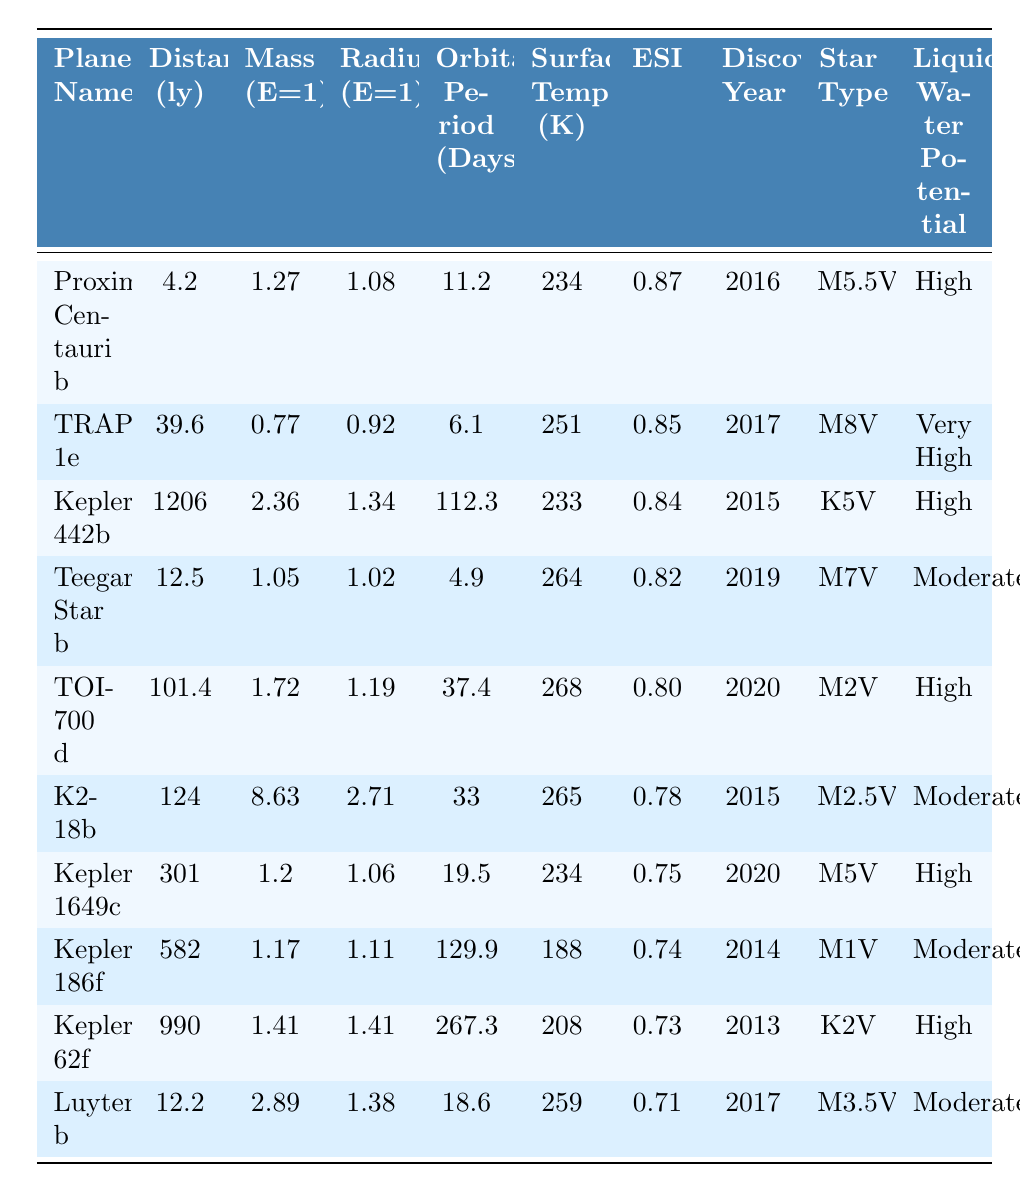What is the mass of TRAPPIST-1e in Earth masses? Looking at the row for TRAPPIST-1e, the mass is listed as 0.77 Earth masses.
Answer: 0.77 Which planet has the highest potential for liquid water? By examining the last column of the table, TRAPPIST-1e has the highest potential for liquid water, categorized as "Very High."
Answer: TRAPPIST-1e What is the distance of Kepler-62f in light-years? The distance entry for Kepler-62f in the table is 990 light-years.
Answer: 990 Calculate the average radius of planets with high potential for liquid water. The planets with high potential for liquid water are Proxima Centauri b, TRAPPIST-1e, Kepler-442b, TOI-700 d, Kepler-1649c, and Kepler-62f. Their radii are 1.08, 0.92, 1.34, 1.19, 1.06, and 1.41 respectively. Adding these gives 1.08 + 0.92 + 1.34 + 1.19 + 1.06 + 1.41 = 6.00. There are 6 planets, so the average radius is 6.00 / 6 = 1.00.
Answer: 1.00 Which planet discovered in 2019 has the highest surface temperature? Looking at the year column for 2019, the candidates are Teegarden's Star b, which has a surface temperature of 264 K. Checking the data shows that it is the only planet from 2019, so it is inherently the highest.
Answer: Teegarden's Star b Is K2-18b more massive than Proxima Centauri b? From the table, K2-18b has a mass of 8.63, while Proxima Centauri b has a mass of 1.27. Since 8.63 is greater than 1.27, K2-18b is indeed more massive than Proxima Centauri b.
Answer: Yes What is the orbital period of the planet with the highest ESI? The planet with the highest ESI is Proxima Centauri b with an ESI of 0.87, and its orbital period is listed as 11.2 days in the table.
Answer: 11.2 days How many planets discovered after 2018 have a moderate potential for liquid water? The planets discovered after 2018 are TOI-700 d (2020), K2-18b (2015), Kepler-1649c (2020), Kepler-186f (2014), Kepler-62f (2013), and Luyten b (2017). Among these, TOI-700 d (2020) and K2-18b (2015) have a moderate potential, making it two planets.
Answer: 2 Which star type is associated with the planet having a mass closest to 1 Earth mass? Looking closely, the planet closest to 1 Earth mass is Teegarden's Star b with a mass of 1.05. Its star type is M7V.
Answer: M7V What is the mass difference between the heaviest and lightest planets on the list? The heaviest planet is K2-18b with a mass of 8.63, and the lightest is TRAPPIST-1e with a mass of 0.77. The difference is calculated as 8.63 - 0.77 = 7.86.
Answer: 7.86 